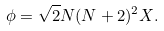<formula> <loc_0><loc_0><loc_500><loc_500>\phi = \sqrt { 2 } N ( N + 2 ) ^ { 2 } X .</formula> 